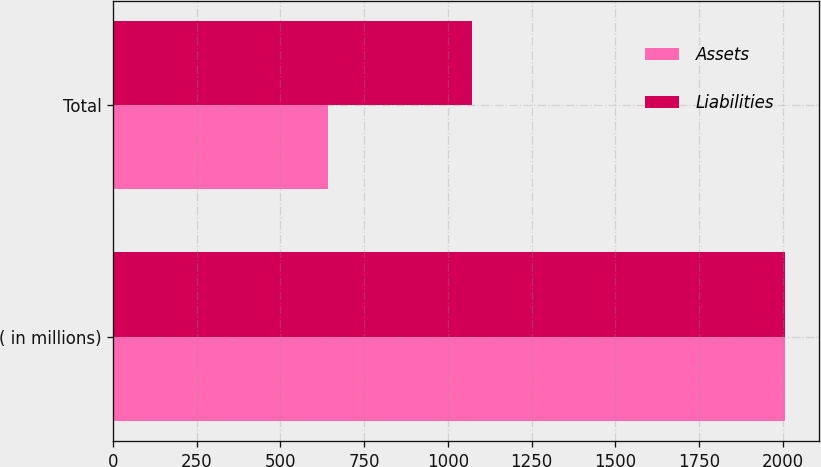Convert chart to OTSL. <chart><loc_0><loc_0><loc_500><loc_500><stacked_bar_chart><ecel><fcel>( in millions)<fcel>Total<nl><fcel>Assets<fcel>2008<fcel>641<nl><fcel>Liabilities<fcel>2008<fcel>1072<nl></chart> 